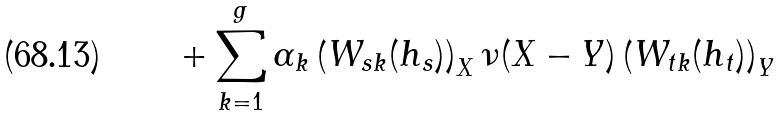Convert formula to latex. <formula><loc_0><loc_0><loc_500><loc_500>+ \sum _ { k = 1 } ^ { g } \alpha _ { k } \left ( W _ { s k } ( h _ { s } ) \right ) _ { X } \nu ( X - Y ) \left ( W _ { t k } ( h _ { t } ) \right ) _ { Y }</formula> 